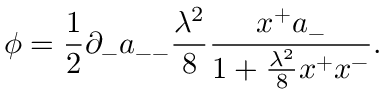Convert formula to latex. <formula><loc_0><loc_0><loc_500><loc_500>\phi = { \frac { 1 } { 2 } } \partial _ { - } a _ { - - } { \frac { \lambda ^ { 2 } } { 8 } } { \frac { x ^ { + } a _ { - } } { 1 + { \frac { \lambda ^ { 2 } } { 8 } } x ^ { + } x ^ { - } } } .</formula> 